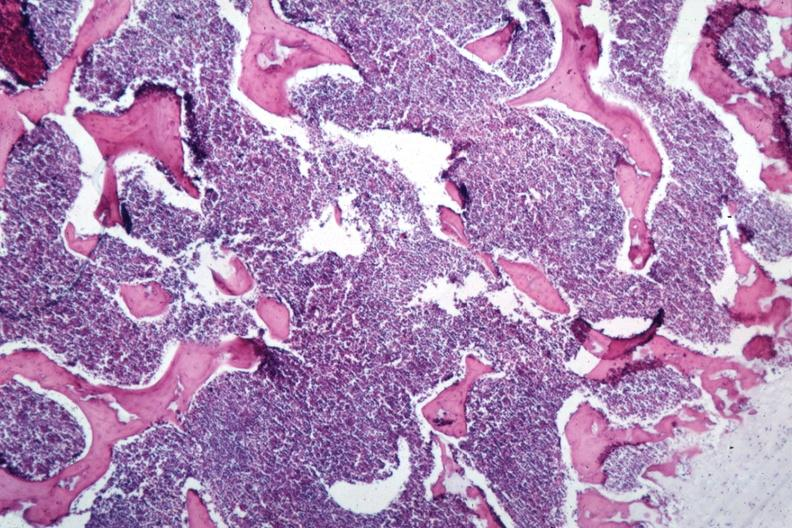s metastatic carcinoma oat cell present?
Answer the question using a single word or phrase. No 